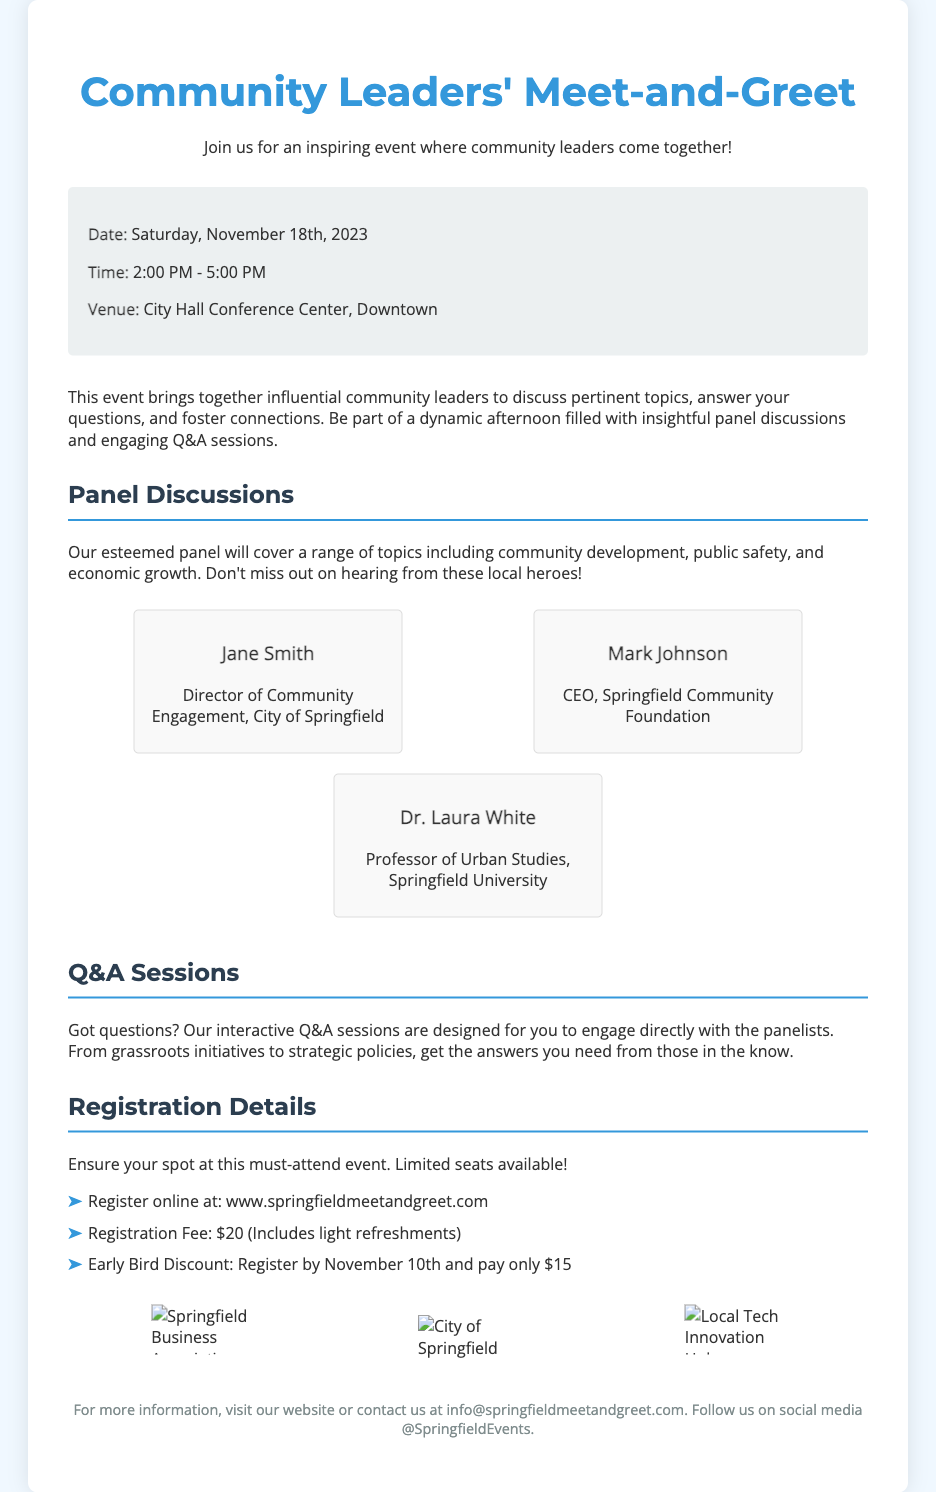What is the date of the event? The date of the event is explicitly mentioned in the document as Saturday, November 18th, 2023.
Answer: Saturday, November 18th, 2023 What time does the event start? The starting time for the event is stated as 2:00 PM, which is listed in the event details.
Answer: 2:00 PM Who is the Director of Community Engagement? The document lists Jane Smith as the Director of Community Engagement, providing her title and affiliation.
Answer: Jane Smith What is the registration fee? The registration fee is provided in the registration details section of the document as $20.
Answer: $20 What will be covered in the panel discussions? The document mentions that panel discussions will cover topics such as community development, public safety, and economic growth.
Answer: community development, public safety, and economic growth How can attendees register for the event? The document gives the registration method as registering online at the specified website.
Answer: www.springfieldmeetandgreet.com What is the early bird discount price? The early bird discount price is clearly mentioned as $15 for those who register by November 10th.
Answer: $15 How many panelists are listed in the document? The document shows three panelists in the panelist section.
Answer: Three What type of refreshments are included in the registration fee? The document states that light refreshments are included with the registration fee.
Answer: light refreshments 